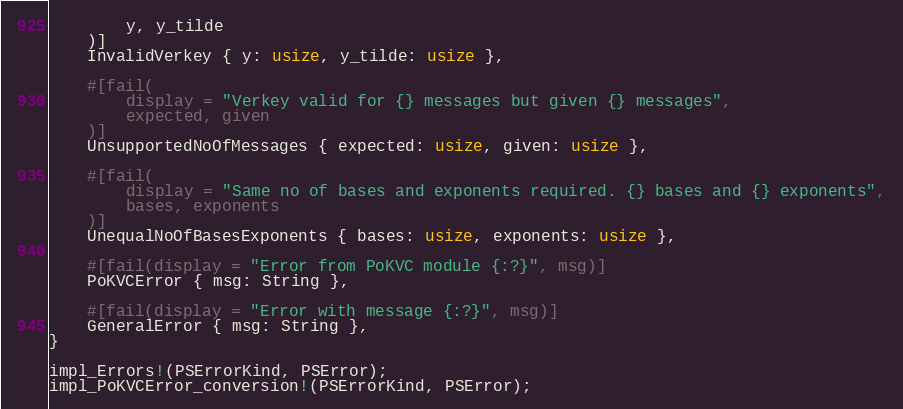<code> <loc_0><loc_0><loc_500><loc_500><_Rust_>        y, y_tilde
    )]
    InvalidVerkey { y: usize, y_tilde: usize },

    #[fail(
        display = "Verkey valid for {} messages but given {} messages",
        expected, given
    )]
    UnsupportedNoOfMessages { expected: usize, given: usize },

    #[fail(
        display = "Same no of bases and exponents required. {} bases and {} exponents",
        bases, exponents
    )]
    UnequalNoOfBasesExponents { bases: usize, exponents: usize },

    #[fail(display = "Error from PoKVC module {:?}", msg)]
    PoKVCError { msg: String },

    #[fail(display = "Error with message {:?}", msg)]
    GeneralError { msg: String },
}

impl_Errors!(PSErrorKind, PSError);
impl_PoKVCError_conversion!(PSErrorKind, PSError);
</code> 